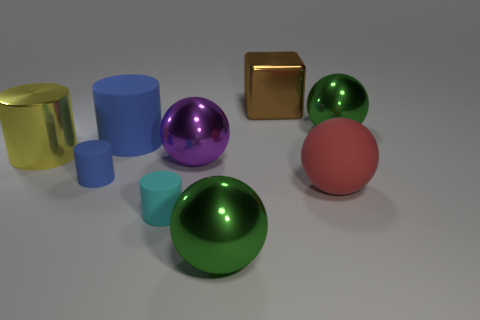How many rubber cylinders have the same color as the block?
Offer a very short reply. 0. How many things are either large objects on the left side of the purple shiny object or large green metallic things?
Offer a terse response. 4. There is a ball that is the same material as the big blue cylinder; what color is it?
Your answer should be compact. Red. Are there any other red objects that have the same size as the red matte thing?
Your response must be concise. No. How many things are either large green balls on the left side of the cube or metallic things in front of the brown cube?
Keep it short and to the point. 4. There is a blue matte thing that is the same size as the brown cube; what is its shape?
Your response must be concise. Cylinder. Are there any tiny green metal objects of the same shape as the big yellow thing?
Offer a very short reply. No. Are there fewer purple shiny things than green metallic things?
Keep it short and to the point. Yes. There is a metallic sphere that is behind the large yellow cylinder; is it the same size as the green thing that is in front of the small blue cylinder?
Keep it short and to the point. Yes. How many things are red spheres or metal blocks?
Give a very brief answer. 2. 